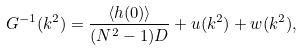Convert formula to latex. <formula><loc_0><loc_0><loc_500><loc_500>G ^ { - 1 } ( k ^ { 2 } ) = \frac { \langle h ( 0 ) \rangle } { ( N ^ { 2 } - 1 ) D } + u ( k ^ { 2 } ) + w ( k ^ { 2 } ) ,</formula> 